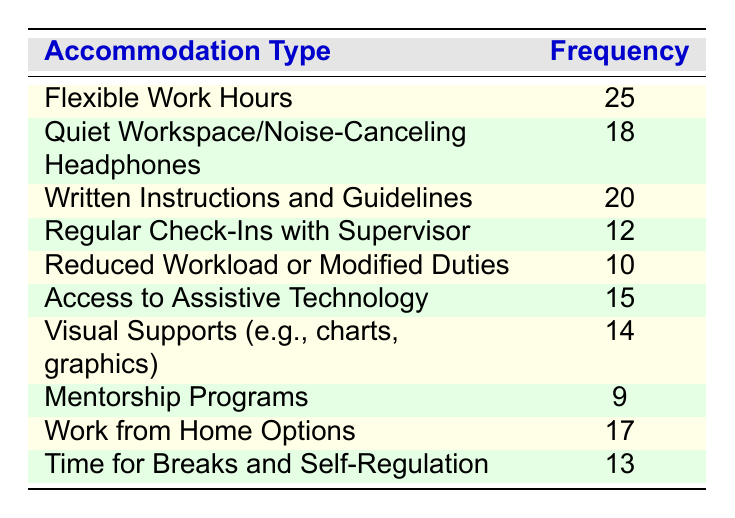What is the most requested workplace accommodation? The table shows that "Flexible Work Hours" has the highest frequency with 25 requests, which is greater than all other accommodations listed.
Answer: Flexible Work Hours How many employees requested access to assistive technology? The frequency for "Access to Assistive Technology" in the table is 15, indicating that 15 employees requested this accommodation.
Answer: 15 What is the combined frequency of requests for "Quiet Workspace/Noise-Canceling Headphones" and "Work from Home Options"? The frequency for "Quiet Workspace/Noise-Canceling Headphones" is 18, and for "Work from Home Options," it is 17. Adding these together (18 + 17) gives a total of 35 requests for these two accommodations.
Answer: 35 Is it true that more employees requested "Written Instructions and Guidelines" than "Time for Breaks and Self-Regulation"? The frequency for "Written Instructions and Guidelines" is 20, while for "Time for Breaks and Self-Regulation," it is 13. Since 20 is greater than 13, the statement is true.
Answer: Yes What is the median frequency of the requested accommodations? To find the median, first, we need to list the frequencies in order: 9, 10, 12, 13, 14, 15, 17, 18, 20, 25. There are 10 values, so the median is the average of the 5th and 6th values (14 and 15). Thus, (14 + 15) / 2 = 14.5.
Answer: 14.5 How many accommodation types were requested by fewer than 15 employees? The accommodations with fewer than 15 requests in the table are "Mentorship Programs" (9), "Reduced Workload or Modified Duties" (10), and "Regular Check-Ins with Supervisor" (12). Counting these gives a total of 3 types.
Answer: 3 What is the difference in frequency between the highest and lowest requested accommodations? The highest frequency is for "Flexible Work Hours" at 25 requests, and the lowest is for "Mentorship Programs," which has 9 requests. The difference (25 - 9) is 16.
Answer: 16 How many accommodations had a frequency of 15 or more requests? The accommodations with 15 or more requests are "Flexible Work Hours" (25), "Written Instructions and Guidelines" (20), "Quiet Workspace/Noise-Canceling Headphones" (18), "Work from Home Options" (17), and "Access to Assistive Technology" (15). This totals 5 accommodations.
Answer: 5 